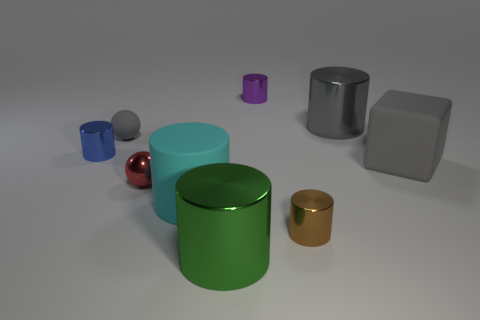Which objects seem to be made of metal and how can you tell? The objects that appear to be made of metal include the green and silver cylinders on the left and the gold cylinder on the right. You can tell they are likely metal based on their reflective surfaces, which are characteristic of metal objects due to their highly polished finish that clearly mirrors the environmental lighting. 